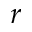Convert formula to latex. <formula><loc_0><loc_0><loc_500><loc_500>r</formula> 